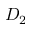<formula> <loc_0><loc_0><loc_500><loc_500>D _ { 2 }</formula> 